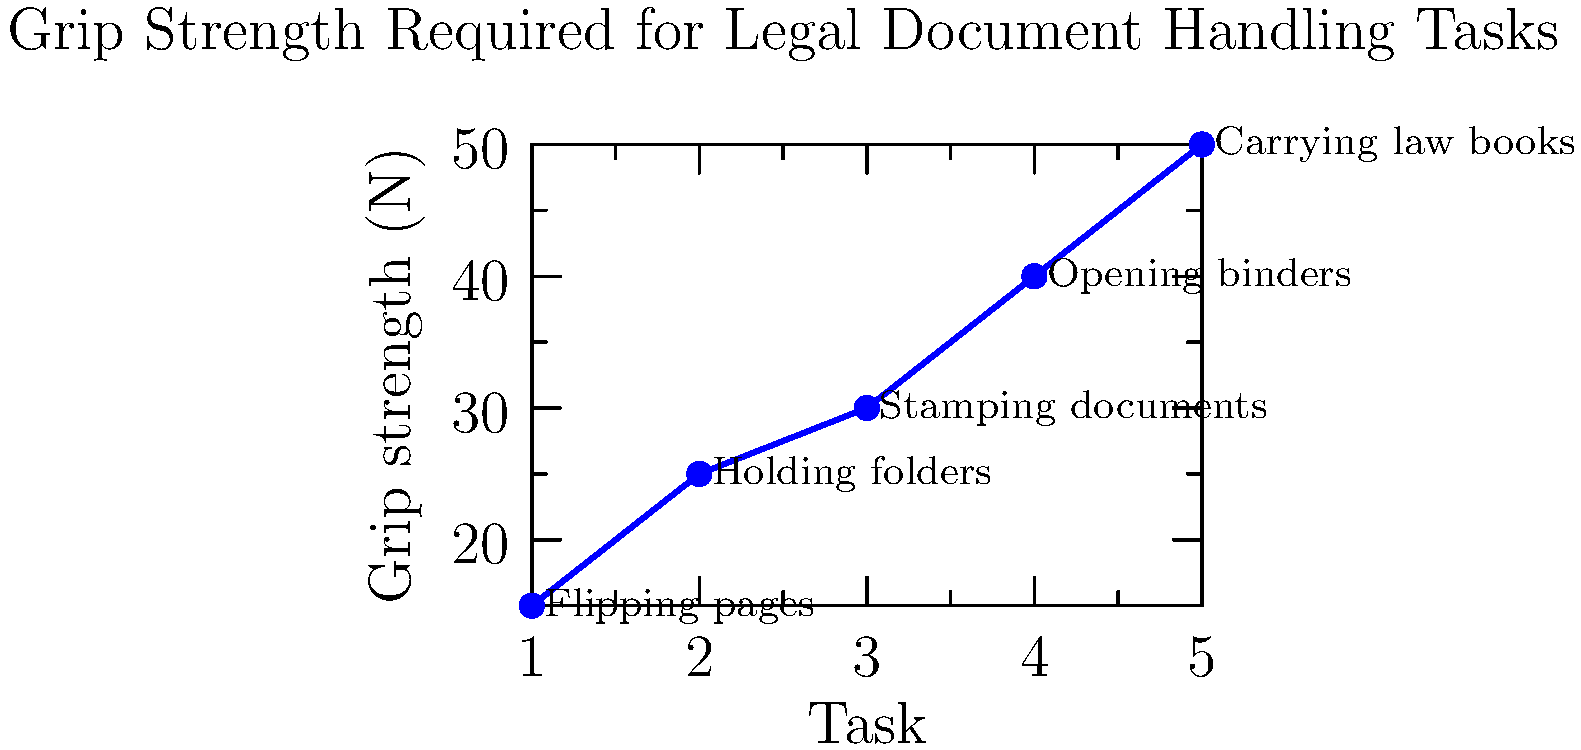Based on the graph showing grip strength required for different legal document handling tasks, which task requires the highest grip strength, and how much stronger is it compared to the task requiring the least grip strength? To answer this question, we need to follow these steps:

1. Identify the task requiring the highest grip strength:
   From the graph, we can see that "Carrying law books" requires the highest grip strength at 50 N.

2. Identify the task requiring the lowest grip strength:
   The task with the lowest grip strength is "Flipping pages" at 15 N.

3. Calculate the difference in grip strength:
   Difference = Highest grip strength - Lowest grip strength
               = 50 N - 15 N = 35 N

4. Calculate how much stronger the highest is compared to the lowest:
   Ratio = Highest grip strength / Lowest grip strength
         = 50 N / 15 N = 3.33 (rounded to two decimal places)

Therefore, carrying law books requires 3.33 times more grip strength than flipping pages.
Answer: Carrying law books; 3.33 times stronger 